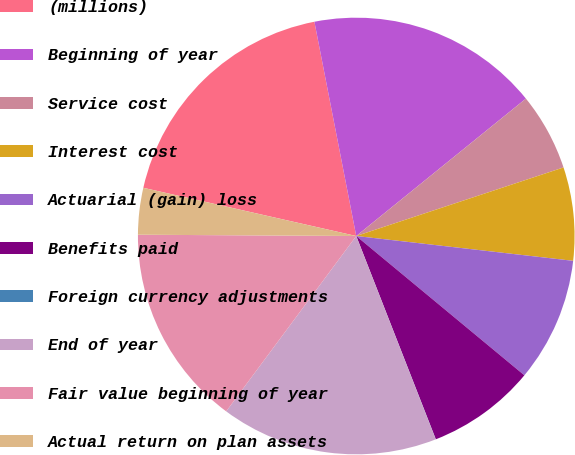Convert chart. <chart><loc_0><loc_0><loc_500><loc_500><pie_chart><fcel>(millions)<fcel>Beginning of year<fcel>Service cost<fcel>Interest cost<fcel>Actuarial (gain) loss<fcel>Benefits paid<fcel>Foreign currency adjustments<fcel>End of year<fcel>Fair value beginning of year<fcel>Actual return on plan assets<nl><fcel>18.39%<fcel>17.24%<fcel>5.75%<fcel>6.9%<fcel>9.2%<fcel>8.05%<fcel>0.01%<fcel>16.09%<fcel>14.94%<fcel>3.45%<nl></chart> 